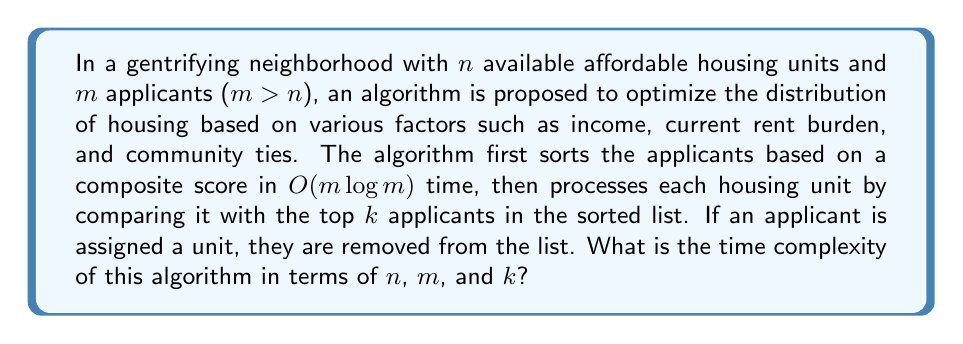Can you answer this question? To analyze the time complexity of this algorithm, we need to break it down into its main components:

1. Sorting the applicants: $O(m \log m)$

2. Processing each housing unit:
   - For each of the $n$ units:
     - Compare with top $k$ applicants: $O(k)$
     - If assigned, remove from list: $O(\log m)$ (assuming a balanced binary search tree implementation)

   Total for processing: $O(n(k + \log m))$

3. Combining the steps:
   $O(m \log m + n(k + \log m))$

We can simplify this expression:

- Since $m > n$, $\log m > \log n$
- The $n \log m$ term is dominated by $m \log m$

Therefore, the final time complexity is:

$$O(m \log m + nk)$$

This complexity reflects the balance between the initial sorting of all applicants and the per-unit processing cost. The algorithm attempts to optimize affordable housing distribution by considering a subset of top applicants for each unit, which may help preserve some community ties in the face of gentrification.
Answer: $O(m \log m + nk)$ 